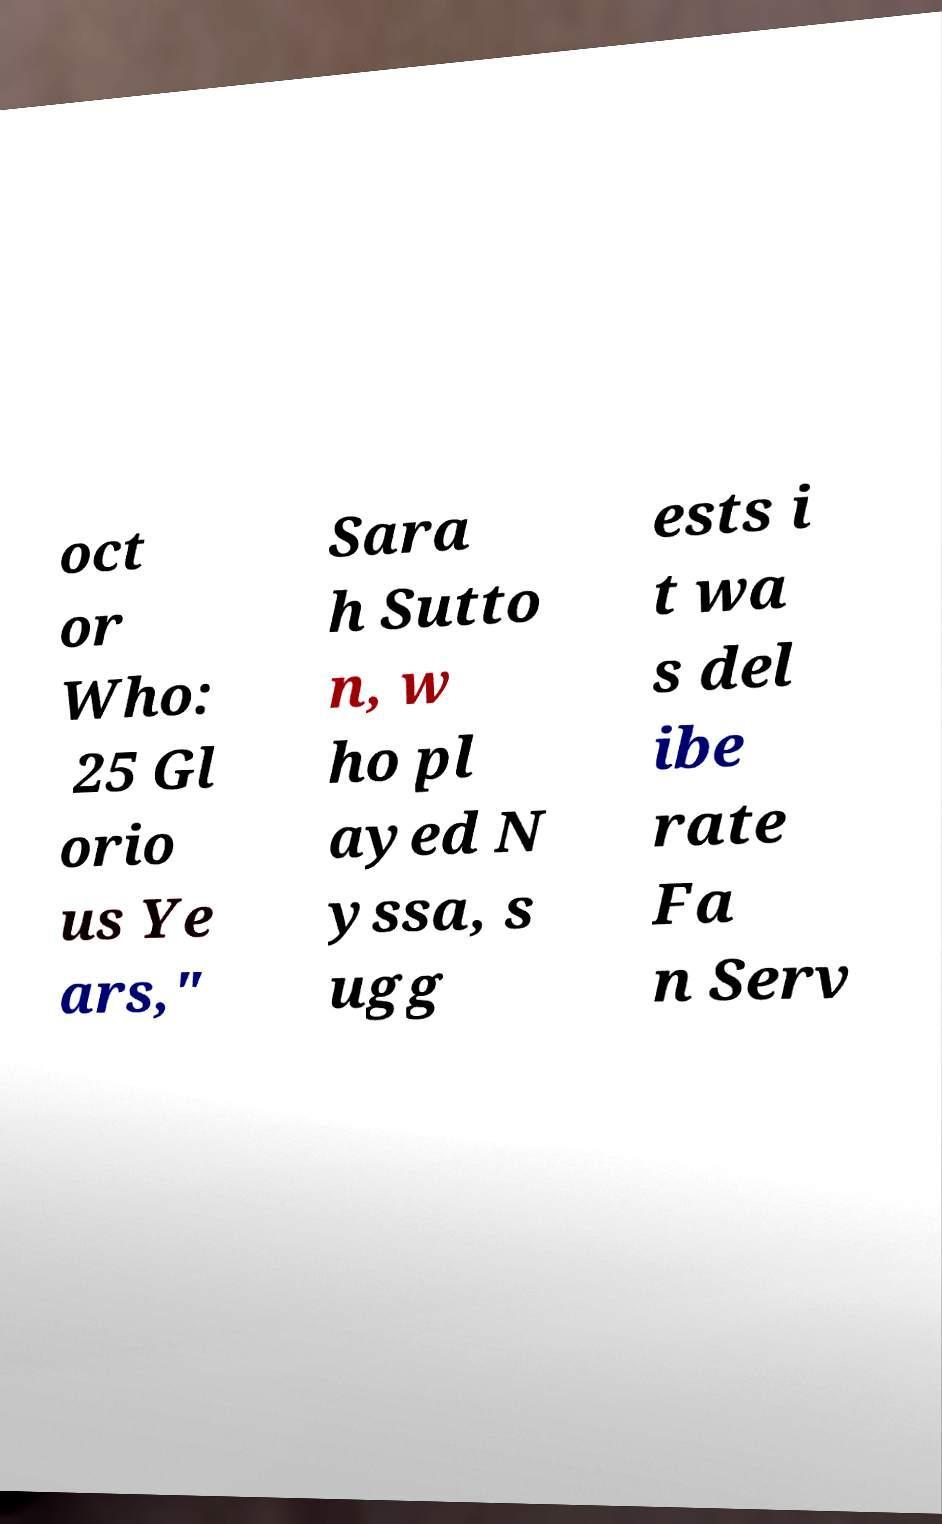Please identify and transcribe the text found in this image. oct or Who: 25 Gl orio us Ye ars," Sara h Sutto n, w ho pl ayed N yssa, s ugg ests i t wa s del ibe rate Fa n Serv 